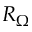Convert formula to latex. <formula><loc_0><loc_0><loc_500><loc_500>R _ { \Omega }</formula> 